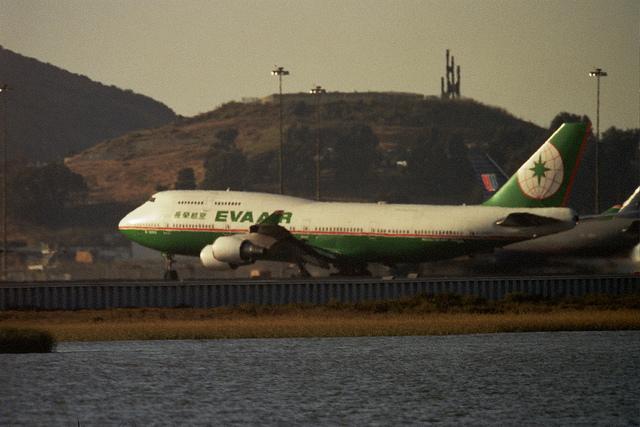Is this a boat?
Short answer required. No. Name two actresses with first names the same as the green letters visible on the plane?
Write a very short answer. Eva longoria, eva mendes. How many light poles are in the photo?
Give a very brief answer. 2. 